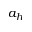Convert formula to latex. <formula><loc_0><loc_0><loc_500><loc_500>a _ { h }</formula> 